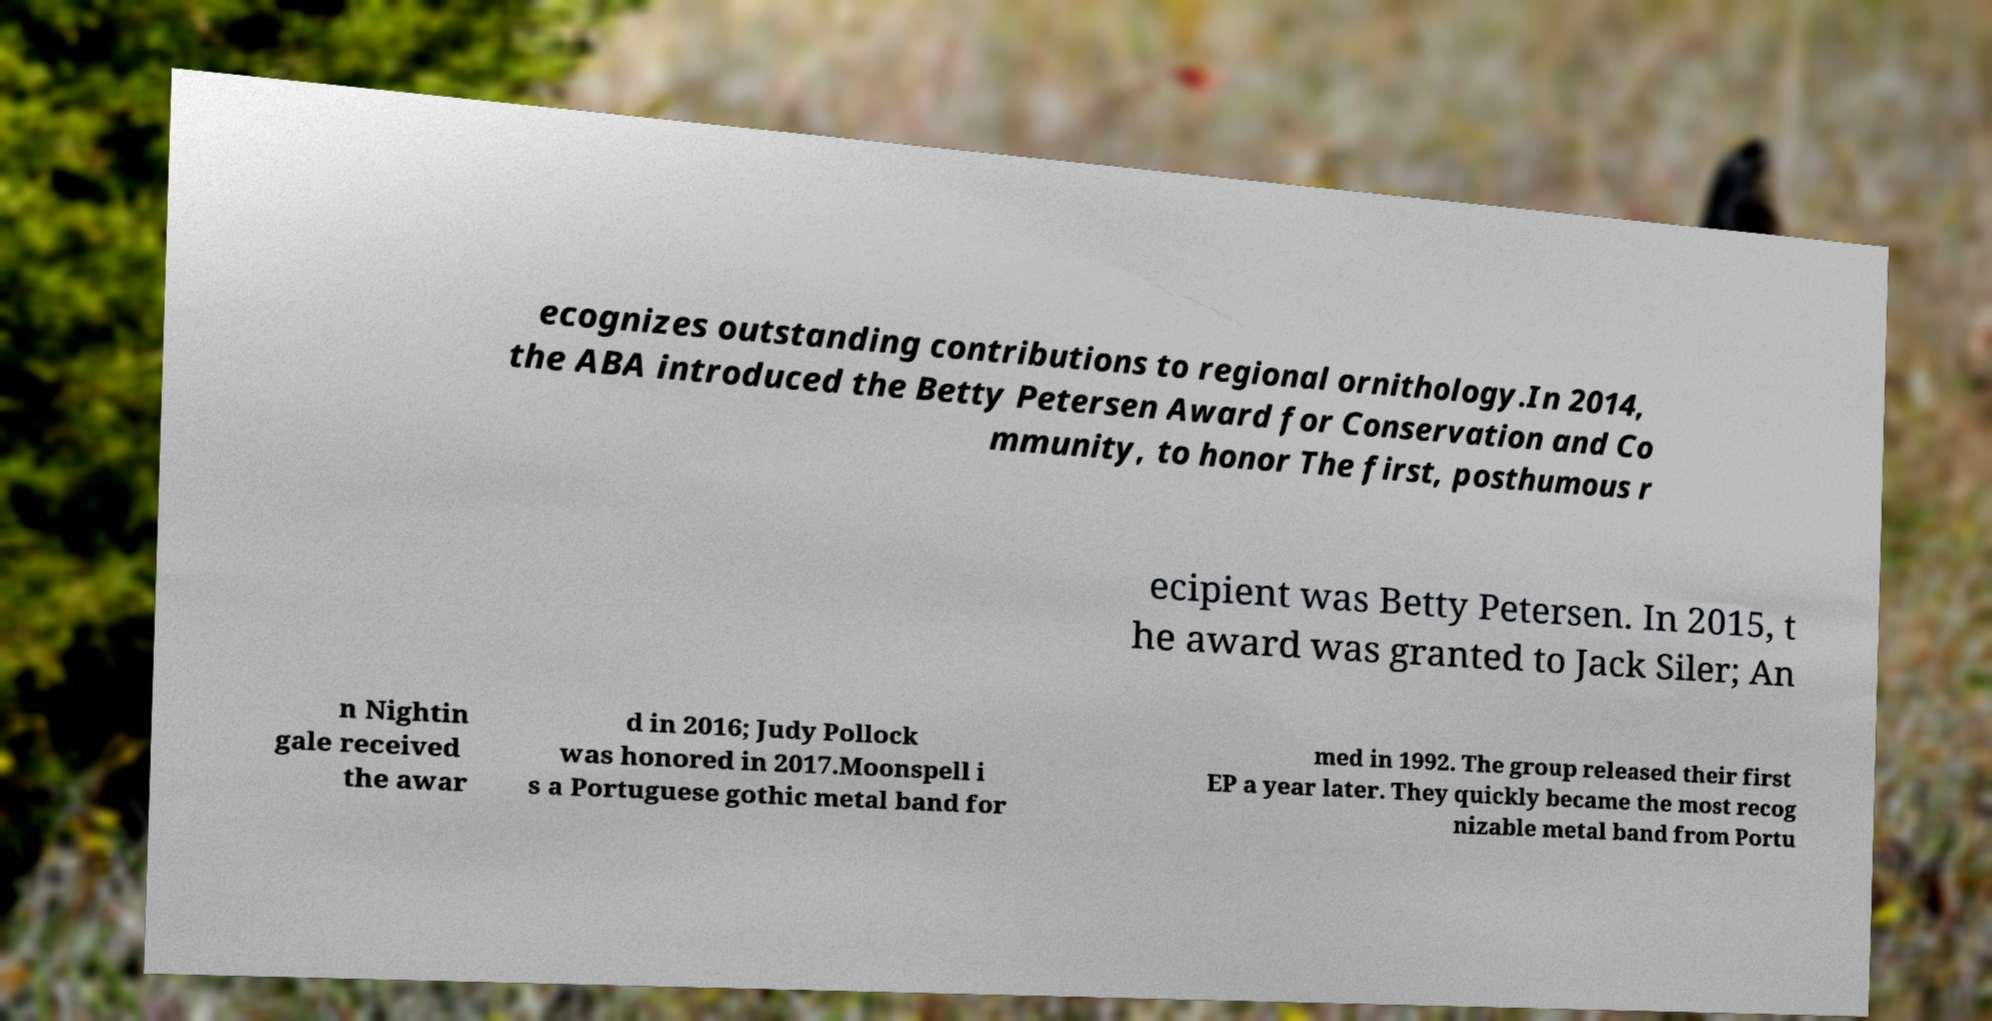Please read and relay the text visible in this image. What does it say? ecognizes outstanding contributions to regional ornithology.In 2014, the ABA introduced the Betty Petersen Award for Conservation and Co mmunity, to honor The first, posthumous r ecipient was Betty Petersen. In 2015, t he award was granted to Jack Siler; An n Nightin gale received the awar d in 2016; Judy Pollock was honored in 2017.Moonspell i s a Portuguese gothic metal band for med in 1992. The group released their first EP a year later. They quickly became the most recog nizable metal band from Portu 